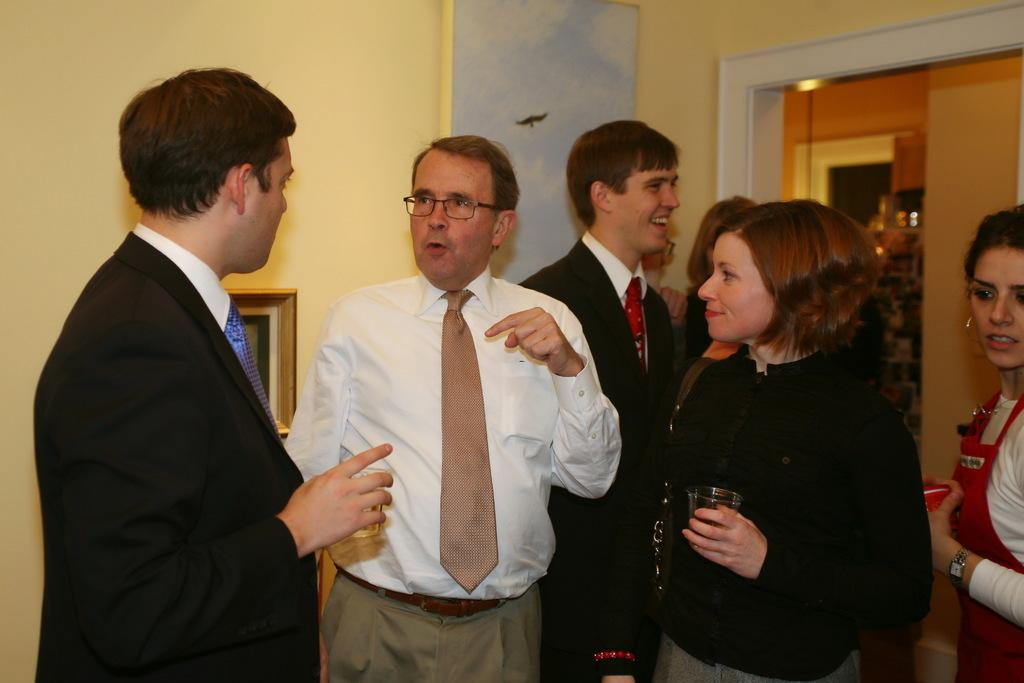Who or what is present in the image? There are people in the image. Where are the people located? The people are in a room. What are some of the people holding in their hands? Some people are holding glasses in their hands. What can be seen in the background of the image? There is a wall in the background of the image. What type of pizzas are being served to the nation in the image? There is no mention of pizzas or a nation in the image; it only features people in a room holding glasses. 